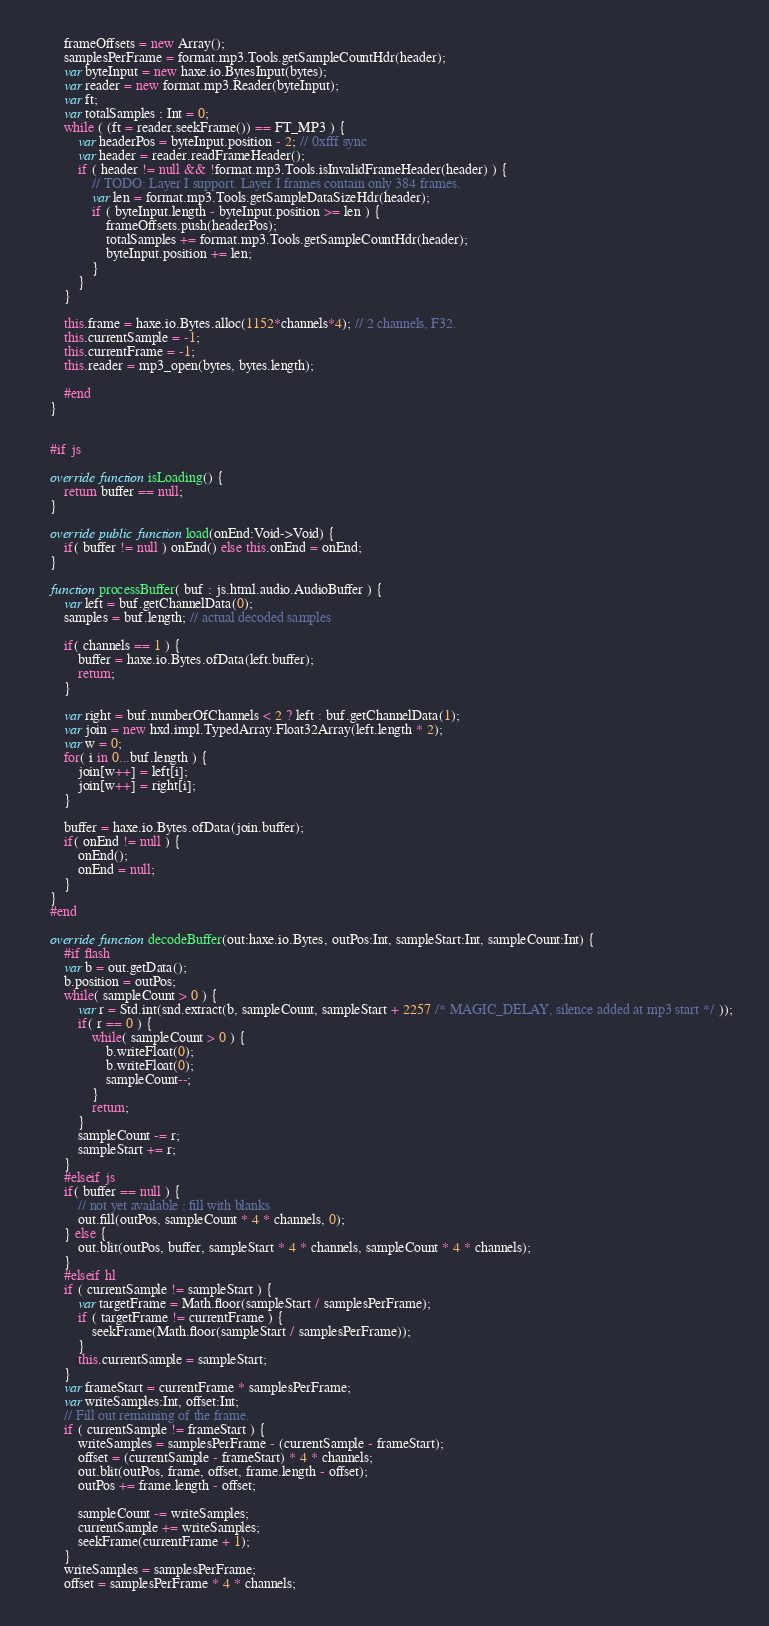Convert code to text. <code><loc_0><loc_0><loc_500><loc_500><_Haxe_>		frameOffsets = new Array();
		samplesPerFrame = format.mp3.Tools.getSampleCountHdr(header);
		var byteInput = new haxe.io.BytesInput(bytes);
		var reader = new format.mp3.Reader(byteInput);
		var ft;
		var totalSamples : Int = 0;
		while ( (ft = reader.seekFrame()) == FT_MP3 ) {
			var headerPos = byteInput.position - 2; // 0xfff sync
			var header = reader.readFrameHeader();
			if ( header != null && !format.mp3.Tools.isInvalidFrameHeader(header) ) {
				// TODO: Layer I support. Layer I frames contain only 384 frames.
				var len = format.mp3.Tools.getSampleDataSizeHdr(header);
				if ( byteInput.length - byteInput.position >= len ) {
					frameOffsets.push(headerPos);
					totalSamples += format.mp3.Tools.getSampleCountHdr(header);
					byteInput.position += len;
				}
			}
		}

		this.frame = haxe.io.Bytes.alloc(1152*channels*4); // 2 channels, F32.
		this.currentSample = -1;
		this.currentFrame = -1;
		this.reader = mp3_open(bytes, bytes.length);

		#end
	}


	#if js

	override function isLoading() {
		return buffer == null;
	}

	override public function load(onEnd:Void->Void) {
		if( buffer != null ) onEnd() else this.onEnd = onEnd;
	}

	function processBuffer( buf : js.html.audio.AudioBuffer ) {
		var left = buf.getChannelData(0);
		samples = buf.length; // actual decoded samples

		if( channels == 1 ) {
			buffer = haxe.io.Bytes.ofData(left.buffer);
			return;
		}

		var right = buf.numberOfChannels < 2 ? left : buf.getChannelData(1);
		var join = new hxd.impl.TypedArray.Float32Array(left.length * 2);
		var w = 0;
		for( i in 0...buf.length ) {
			join[w++] = left[i];
			join[w++] = right[i];
		}

 		buffer = haxe.io.Bytes.ofData(join.buffer);
		if( onEnd != null ) {
			onEnd();
			onEnd = null;
		}
	}
	#end

	override function decodeBuffer(out:haxe.io.Bytes, outPos:Int, sampleStart:Int, sampleCount:Int) {
		#if flash
		var b = out.getData();
		b.position = outPos;
		while( sampleCount > 0 ) {
			var r = Std.int(snd.extract(b, sampleCount, sampleStart + 2257 /* MAGIC_DELAY, silence added at mp3 start */ ));
			if( r == 0 ) {
				while( sampleCount > 0 ) {
					b.writeFloat(0);
					b.writeFloat(0);
					sampleCount--;
				}
				return;
			}
			sampleCount -= r;
			sampleStart += r;
		}
		#elseif js
		if( buffer == null ) {
			// not yet available : fill with blanks
			out.fill(outPos, sampleCount * 4 * channels, 0);
		} else {
			out.blit(outPos, buffer, sampleStart * 4 * channels, sampleCount * 4 * channels);
		}
		#elseif hl
		if ( currentSample != sampleStart ) {
			var targetFrame = Math.floor(sampleStart / samplesPerFrame);
			if ( targetFrame != currentFrame ) {
				seekFrame(Math.floor(sampleStart / samplesPerFrame));
			}
			this.currentSample = sampleStart;
		}
		var frameStart = currentFrame * samplesPerFrame;
		var writeSamples:Int, offset:Int;
		// Fill out remaining of the frame.
		if ( currentSample != frameStart ) {
			writeSamples = samplesPerFrame - (currentSample - frameStart);
			offset = (currentSample - frameStart) * 4 * channels;
			out.blit(outPos, frame, offset, frame.length - offset);
			outPos += frame.length - offset;
			
			sampleCount -= writeSamples;
			currentSample += writeSamples;
			seekFrame(currentFrame + 1);
		}
		writeSamples = samplesPerFrame;
		offset = samplesPerFrame * 4 * channels;</code> 